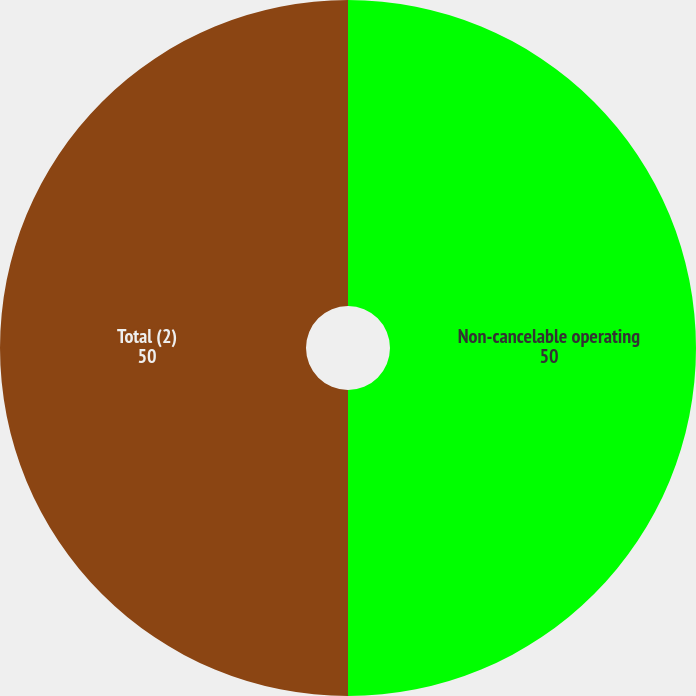<chart> <loc_0><loc_0><loc_500><loc_500><pie_chart><fcel>Non-cancelable operating<fcel>Total (2)<nl><fcel>50.0%<fcel>50.0%<nl></chart> 